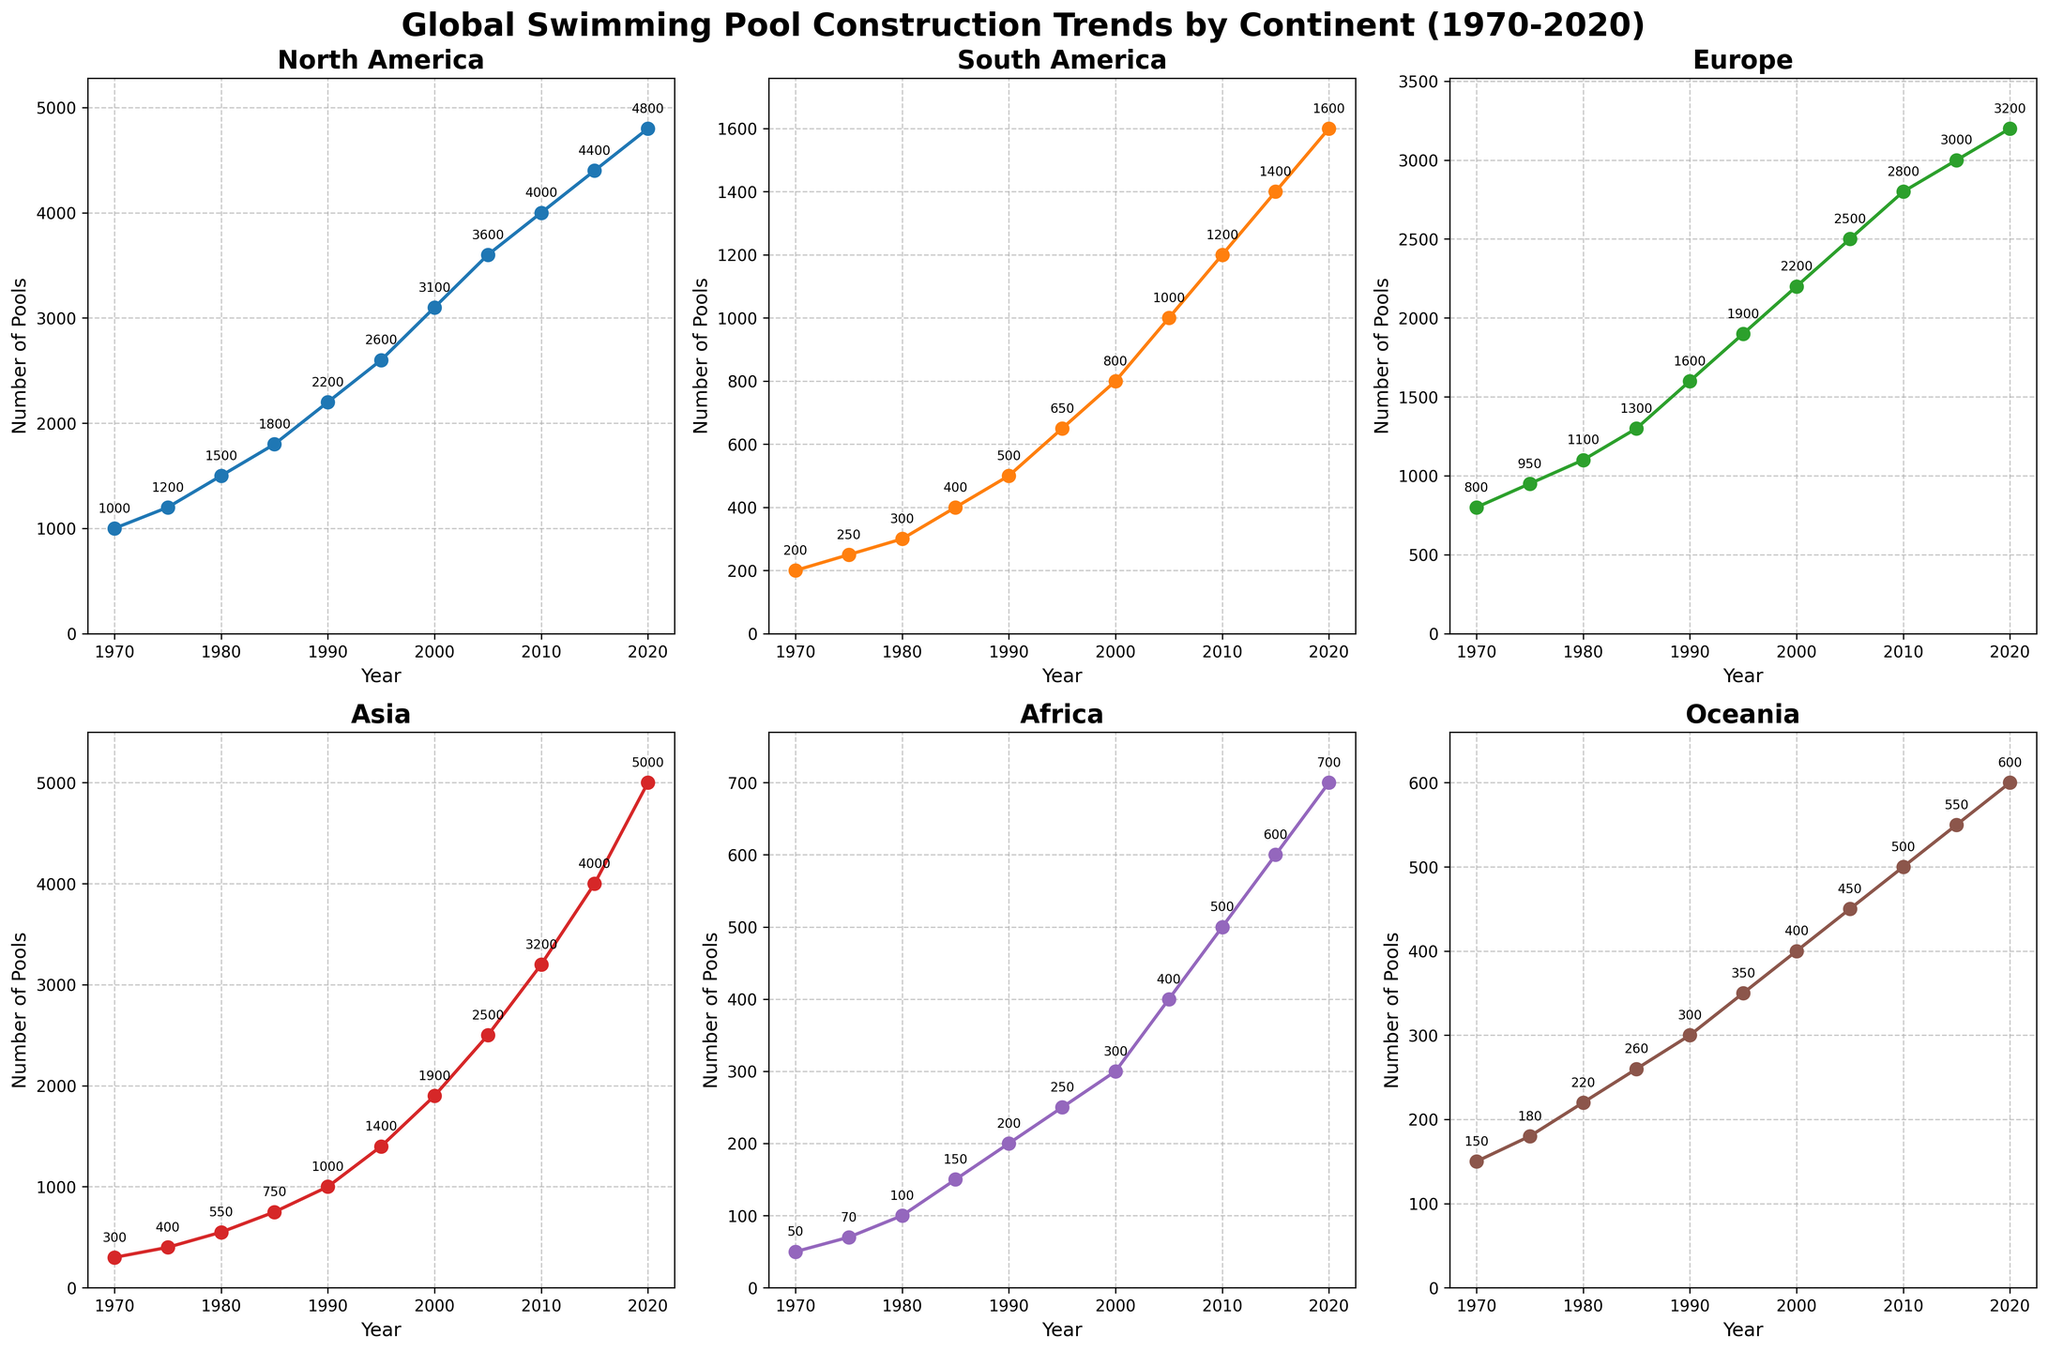What is the overall trend in swimming pool construction in North America from 1970 to 2020? North America shows a steady increase in the number of swimming pools constructed from 1000 in 1970 to 4800 in 2020, indicating a strong upward trend over the past 50 years.
Answer: Upward trend Which continent had the highest number of swimming pools constructed in 2020? Looking at the individual subplots, Asia had the highest number of swimming pools constructed in 2020, with a total of 5000 pools.
Answer: Asia In which year did South America see its largest increase in swimming pool construction compared to the previous period? By examining the plot for South America, the largest increase appears between 2000 (800 pools) and 2005 (1000 pools), an increase of 200 pools.
Answer: 2005 How does the construction trend in Africa compare to that in Oceania from 1970 to 2020? From 1970 to 2020, both Africa and Oceania show upward trends. However, Africa started with fewer pools and has a less steep increase compared to Oceania. For example, in 1970, Africa had 50 pools and Oceania 150; by 2020, Africa had 700 and Oceania 600.
Answer: Less steep increase for Africa What is the average number of swimming pools constructed in Europe from 1970 to 2020? The sum of pools constructed each year in Europe is 800 + 950 + 1100 + 1300 + 1600 + 1900 + 2200 + 2500 + 2800 + 3000 + 3200 = 21350. Dividing by the number of years (11), the average is 21350 / 11 ≈ 1941 pools.
Answer: 1941 pools Which continent had the smallest increase in swimming pool construction from 1970 to 2020? By looking at the differences in pool counts from 1970 to 2020 for each continent, Africa had an increase from 50 to 700 pools, which is smaller compared to other continents, making it the smallest increase.
Answer: Africa What was the total number of swimming pools constructed globally in 1990? Adding the values for each continent in 1990: 2200 (NA) + 500 (SA) + 1600 (Europe) + 1000 (Asia) + 200 (Africa) + 300 (Oceania) = 5800 pools.
Answer: 5800 pools Did any continent experience a decline in swimming pool construction during any of the periods? By examining each subplot, there are no periods where any continent experiences a decline in the number of pools constructed. All trends are either constant or increasing.
Answer: No Between Asia and Europe, which continent saw a steeper increase in pool construction from 2000 to 2020? Asia had 1900 pools in 2000 and 5000 in 2020, an increase of 3100 pools. Europe had 2200 pools in 2000 and 3200 in 2020, an increase of 1000 pools. Asia's increase was steeper during this period.
Answer: Asia What is the difference in the number of pools constructed in Oceania between 1995 and 2005? In 1995, Oceania had 350 pools, and in 2005, it had 450 pools. The difference is 450 - 350 = 100 pools.
Answer: 100 pools 